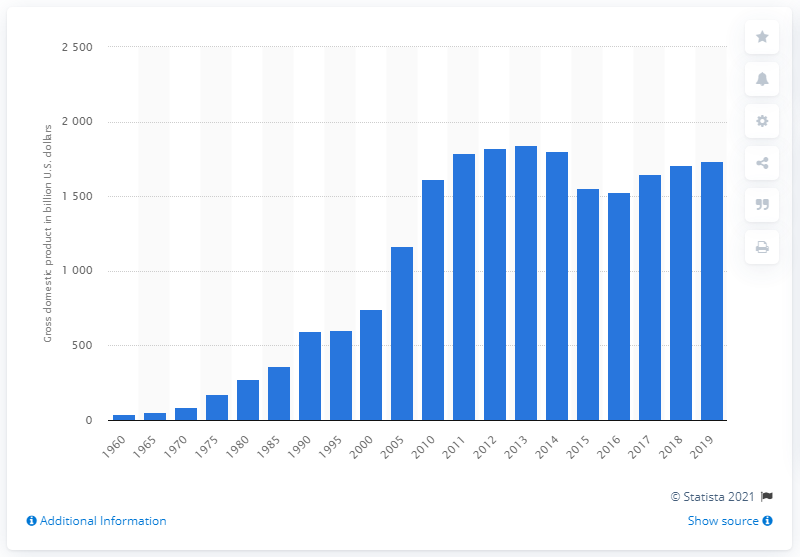Outline some significant characteristics in this image. In 2019, the Gross Domestic Product (GDP) of Canada was valued at 1736.43 dollars. 